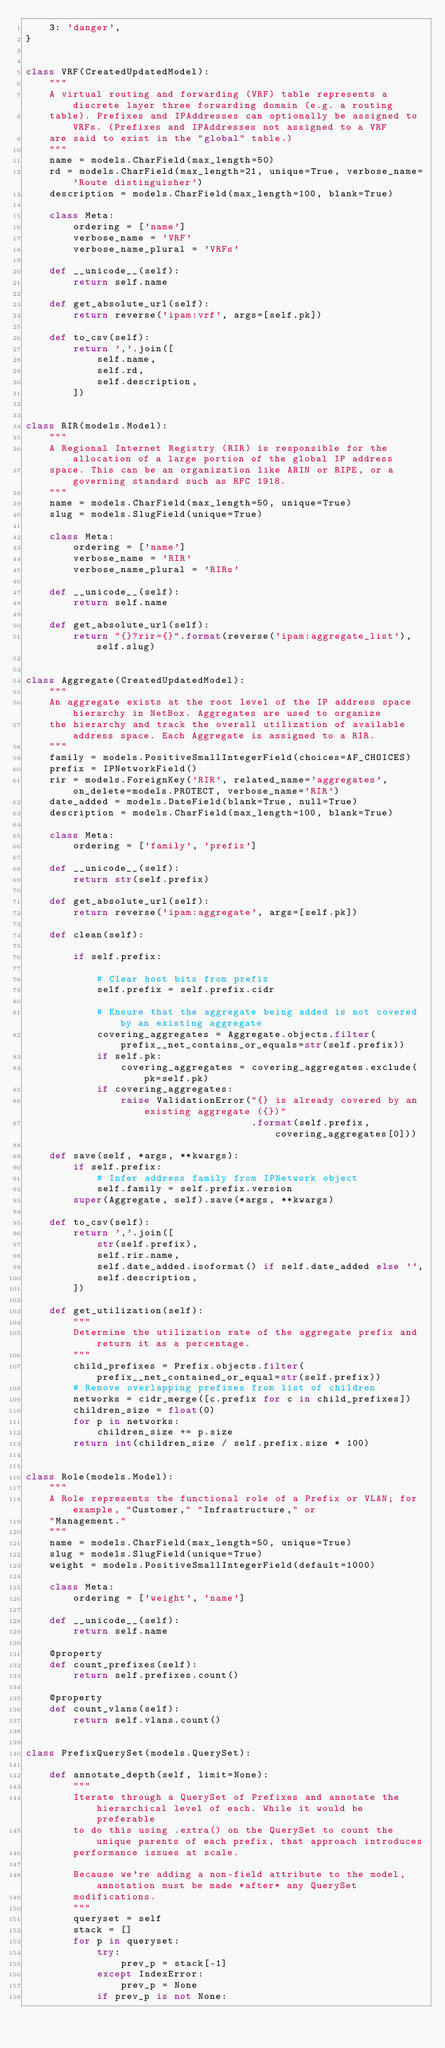Convert code to text. <code><loc_0><loc_0><loc_500><loc_500><_Python_>    3: 'danger',
}


class VRF(CreatedUpdatedModel):
    """
    A virtual routing and forwarding (VRF) table represents a discrete layer three forwarding domain (e.g. a routing
    table). Prefixes and IPAddresses can optionally be assigned to VRFs. (Prefixes and IPAddresses not assigned to a VRF
    are said to exist in the "global" table.)
    """
    name = models.CharField(max_length=50)
    rd = models.CharField(max_length=21, unique=True, verbose_name='Route distinguisher')
    description = models.CharField(max_length=100, blank=True)

    class Meta:
        ordering = ['name']
        verbose_name = 'VRF'
        verbose_name_plural = 'VRFs'

    def __unicode__(self):
        return self.name

    def get_absolute_url(self):
        return reverse('ipam:vrf', args=[self.pk])

    def to_csv(self):
        return ','.join([
            self.name,
            self.rd,
            self.description,
        ])


class RIR(models.Model):
    """
    A Regional Internet Registry (RIR) is responsible for the allocation of a large portion of the global IP address
    space. This can be an organization like ARIN or RIPE, or a governing standard such as RFC 1918.
    """
    name = models.CharField(max_length=50, unique=True)
    slug = models.SlugField(unique=True)

    class Meta:
        ordering = ['name']
        verbose_name = 'RIR'
        verbose_name_plural = 'RIRs'

    def __unicode__(self):
        return self.name

    def get_absolute_url(self):
        return "{}?rir={}".format(reverse('ipam:aggregate_list'), self.slug)


class Aggregate(CreatedUpdatedModel):
    """
    An aggregate exists at the root level of the IP address space hierarchy in NetBox. Aggregates are used to organize
    the hierarchy and track the overall utilization of available address space. Each Aggregate is assigned to a RIR.
    """
    family = models.PositiveSmallIntegerField(choices=AF_CHOICES)
    prefix = IPNetworkField()
    rir = models.ForeignKey('RIR', related_name='aggregates', on_delete=models.PROTECT, verbose_name='RIR')
    date_added = models.DateField(blank=True, null=True)
    description = models.CharField(max_length=100, blank=True)

    class Meta:
        ordering = ['family', 'prefix']

    def __unicode__(self):
        return str(self.prefix)

    def get_absolute_url(self):
        return reverse('ipam:aggregate', args=[self.pk])

    def clean(self):

        if self.prefix:

            # Clear host bits from prefix
            self.prefix = self.prefix.cidr

            # Ensure that the aggregate being added is not covered by an existing aggregate
            covering_aggregates = Aggregate.objects.filter(prefix__net_contains_or_equals=str(self.prefix))
            if self.pk:
                covering_aggregates = covering_aggregates.exclude(pk=self.pk)
            if covering_aggregates:
                raise ValidationError("{} is already covered by an existing aggregate ({})"
                                      .format(self.prefix, covering_aggregates[0]))

    def save(self, *args, **kwargs):
        if self.prefix:
            # Infer address family from IPNetwork object
            self.family = self.prefix.version
        super(Aggregate, self).save(*args, **kwargs)

    def to_csv(self):
        return ','.join([
            str(self.prefix),
            self.rir.name,
            self.date_added.isoformat() if self.date_added else '',
            self.description,
        ])

    def get_utilization(self):
        """
        Determine the utilization rate of the aggregate prefix and return it as a percentage.
        """
        child_prefixes = Prefix.objects.filter(prefix__net_contained_or_equal=str(self.prefix))
        # Remove overlapping prefixes from list of children
        networks = cidr_merge([c.prefix for c in child_prefixes])
        children_size = float(0)
        for p in networks:
            children_size += p.size
        return int(children_size / self.prefix.size * 100)


class Role(models.Model):
    """
    A Role represents the functional role of a Prefix or VLAN; for example, "Customer," "Infrastructure," or
    "Management."
    """
    name = models.CharField(max_length=50, unique=True)
    slug = models.SlugField(unique=True)
    weight = models.PositiveSmallIntegerField(default=1000)

    class Meta:
        ordering = ['weight', 'name']

    def __unicode__(self):
        return self.name

    @property
    def count_prefixes(self):
        return self.prefixes.count()

    @property
    def count_vlans(self):
        return self.vlans.count()


class PrefixQuerySet(models.QuerySet):

    def annotate_depth(self, limit=None):
        """
        Iterate through a QuerySet of Prefixes and annotate the hierarchical level of each. While it would be preferable
        to do this using .extra() on the QuerySet to count the unique parents of each prefix, that approach introduces
        performance issues at scale.

        Because we're adding a non-field attribute to the model, annotation must be made *after* any QuerySet
        modifications.
        """
        queryset = self
        stack = []
        for p in queryset:
            try:
                prev_p = stack[-1]
            except IndexError:
                prev_p = None
            if prev_p is not None:</code> 